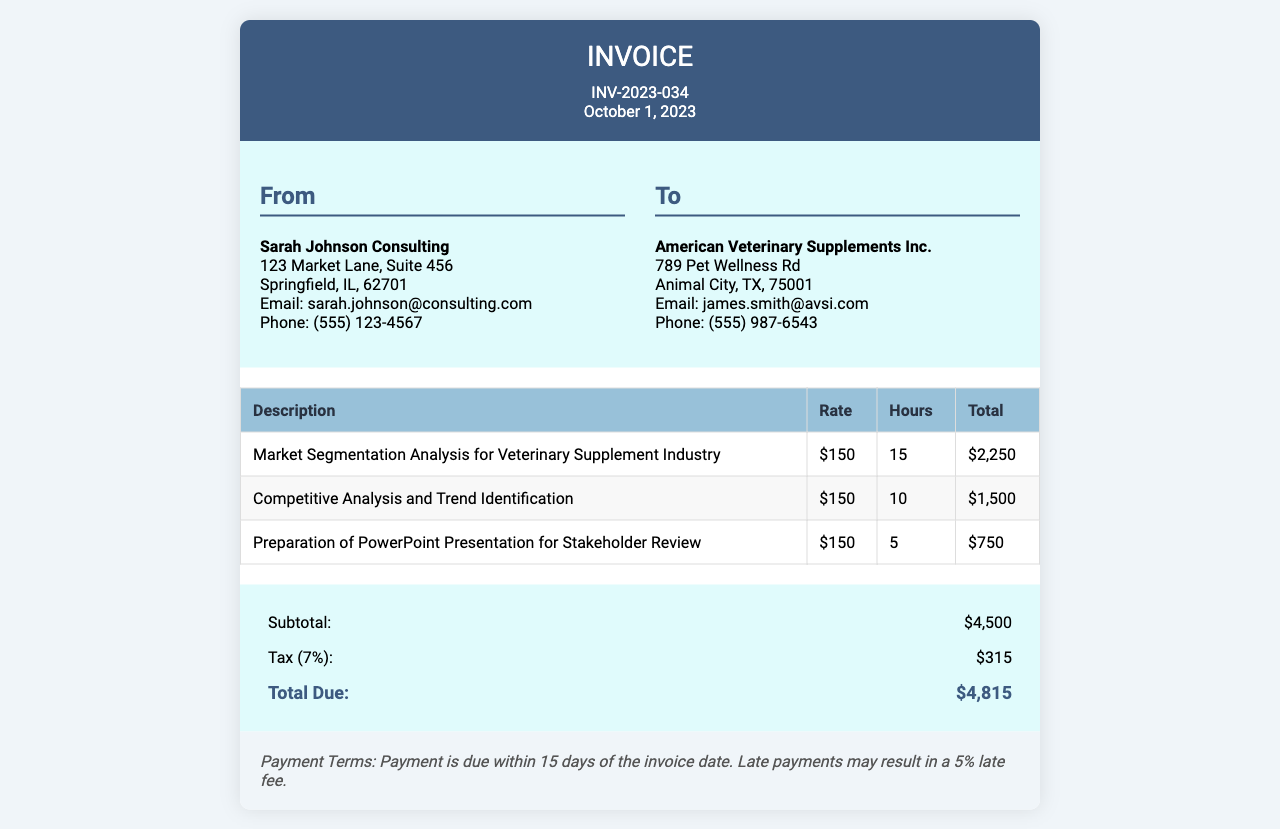What is the invoice number? The invoice number is specifically listed in the header of the document.
Answer: INV-2023-034 What is the total hours worked? The total hours worked can be calculated by summing the hours for each service provided in the document.
Answer: 30 What is the consultant's email address? This information is found in the consultant info section of the document.
Answer: sarah.johnson@consulting.com What is the subtotal before tax? The subtotal is explicitly stated in the summary section of the document.
Answer: $4,500 How much is the tax applied? The tax amount is provided in the summary table under tax.
Answer: $315 Who is the recipient of the invoice? The client information section provides the name of the recipient.
Answer: American Veterinary Supplements Inc What is the hourly rate for services? The hourly rate is listed in the services table for each item provided.
Answer: $150 What is the due date of the payment? The payment terms indicate the timeline for payment due.
Answer: October 16, 2023 What deliverable was prepared for stakeholder review? The services table lists specific deliverables provided by the consultant.
Answer: PowerPoint Presentation for Stakeholder Review 